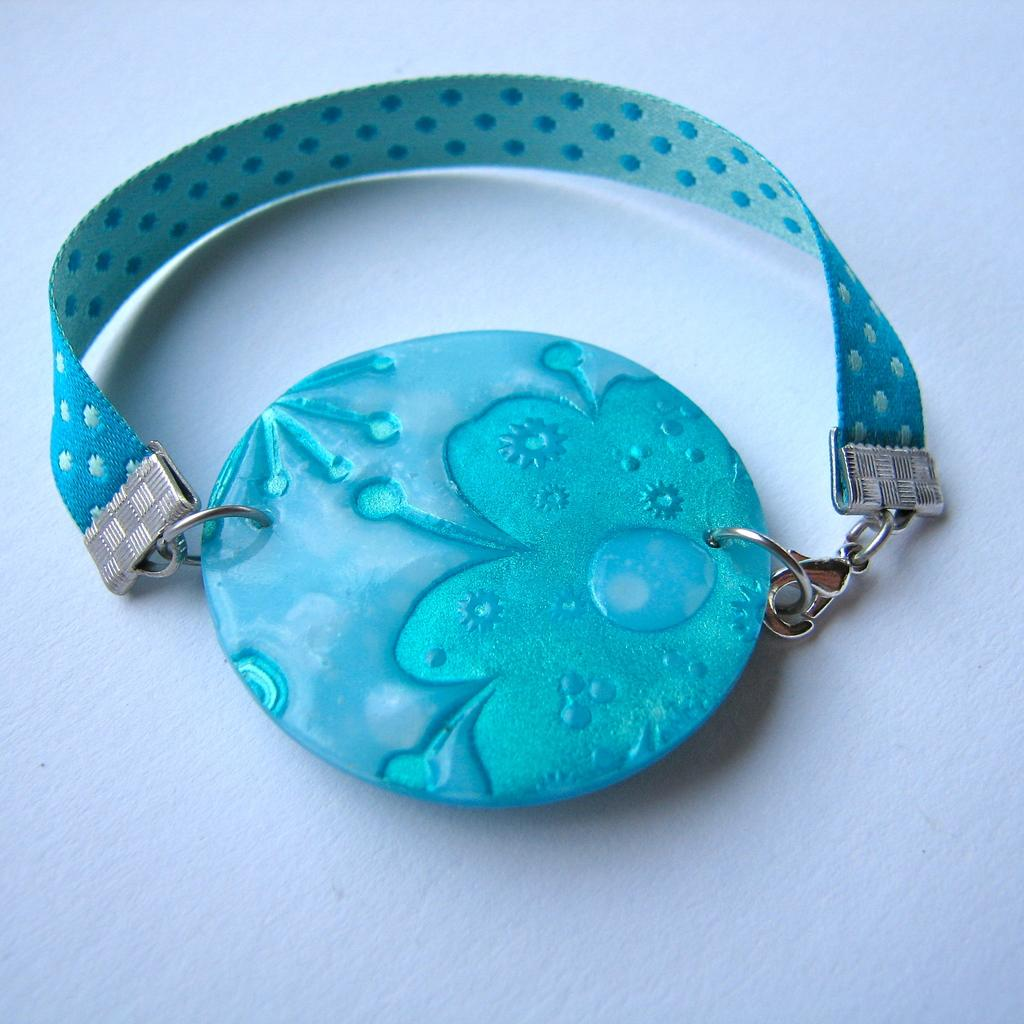What is the main object in the image? There is a chain in the image. What is attached to the chain? There is a locket attached to the chain. What color is the locket? The locket is blue in color. What shape is the stamp in the image? There is no stamp present in the image. What type of journey is depicted in the image? There is no journey depicted in the image; it features a chain with a blue locket attached. 